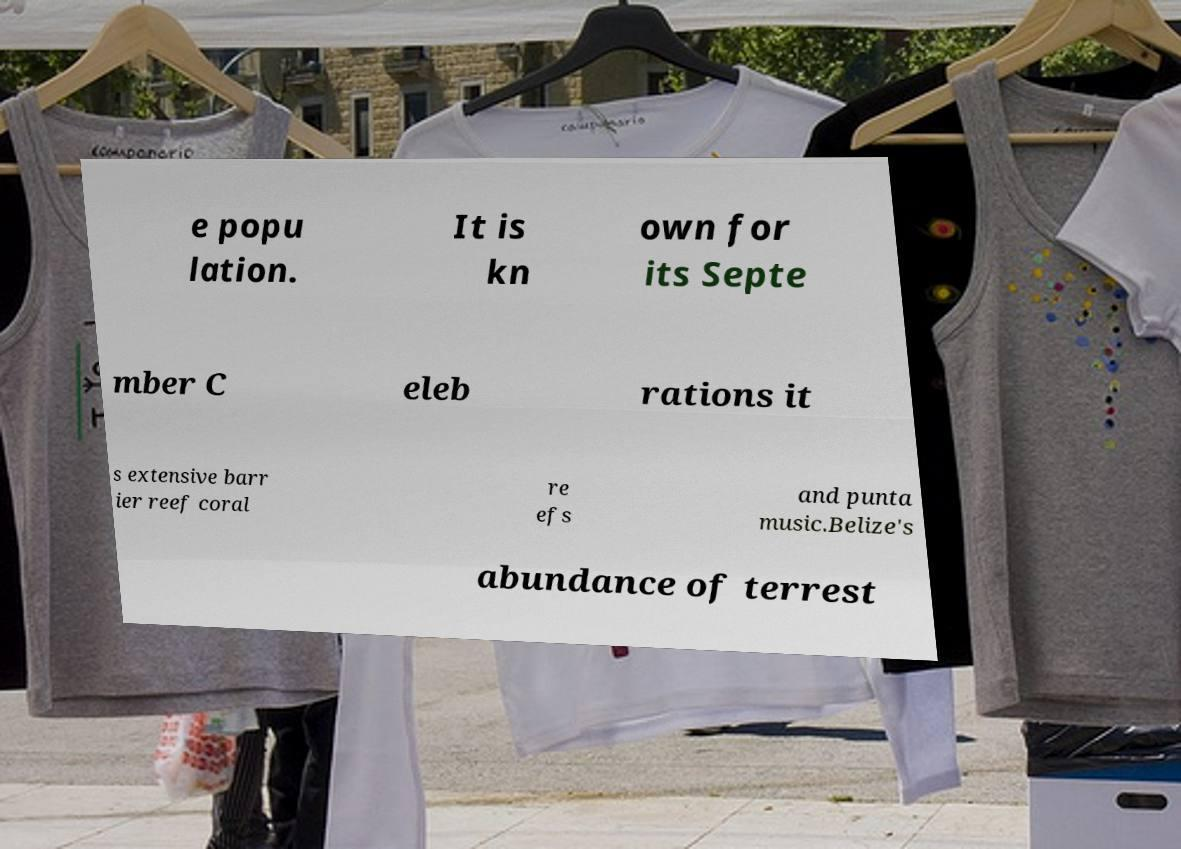What messages or text are displayed in this image? I need them in a readable, typed format. e popu lation. It is kn own for its Septe mber C eleb rations it s extensive barr ier reef coral re efs and punta music.Belize's abundance of terrest 